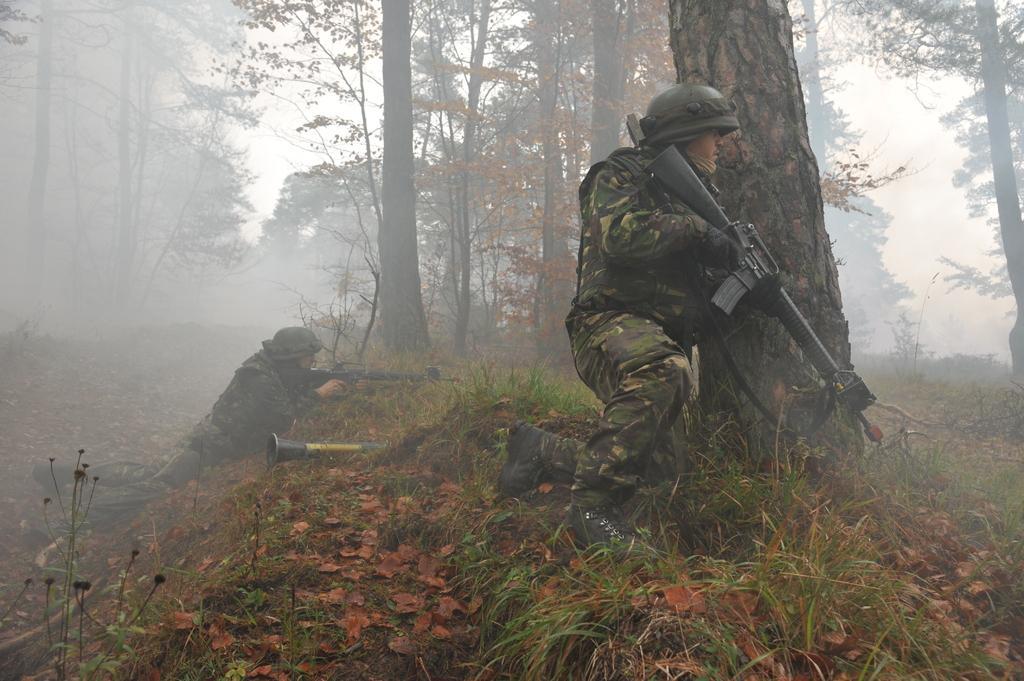How would you summarize this image in a sentence or two? In this picture we can see two persons are holding guns, at the bottom there are some plants and leaves, in the background we can see some trees and fog, these two persons wore helmets and shoes, there is the sky at the top of the picture. 